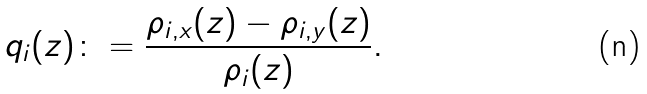<formula> <loc_0><loc_0><loc_500><loc_500>q _ { i } ( z ) \colon = \frac { \rho _ { i , x } ( z ) - \rho _ { i , y } ( z ) } { \rho _ { i } ( z ) } .</formula> 